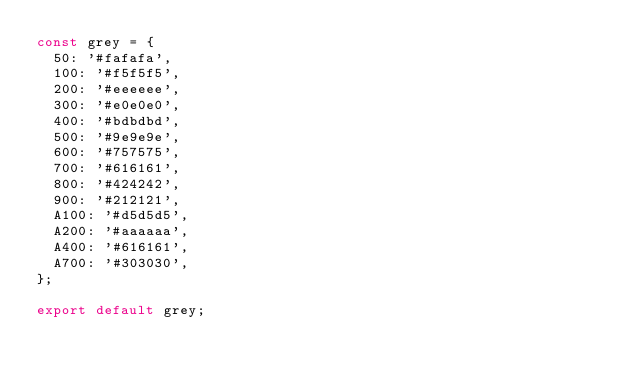Convert code to text. <code><loc_0><loc_0><loc_500><loc_500><_JavaScript_>const grey = {
  50: '#fafafa',
  100: '#f5f5f5',
  200: '#eeeeee',
  300: '#e0e0e0',
  400: '#bdbdbd',
  500: '#9e9e9e',
  600: '#757575',
  700: '#616161',
  800: '#424242',
  900: '#212121',
  A100: '#d5d5d5',
  A200: '#aaaaaa',
  A400: '#616161',
  A700: '#303030',
};

export default grey;
</code> 